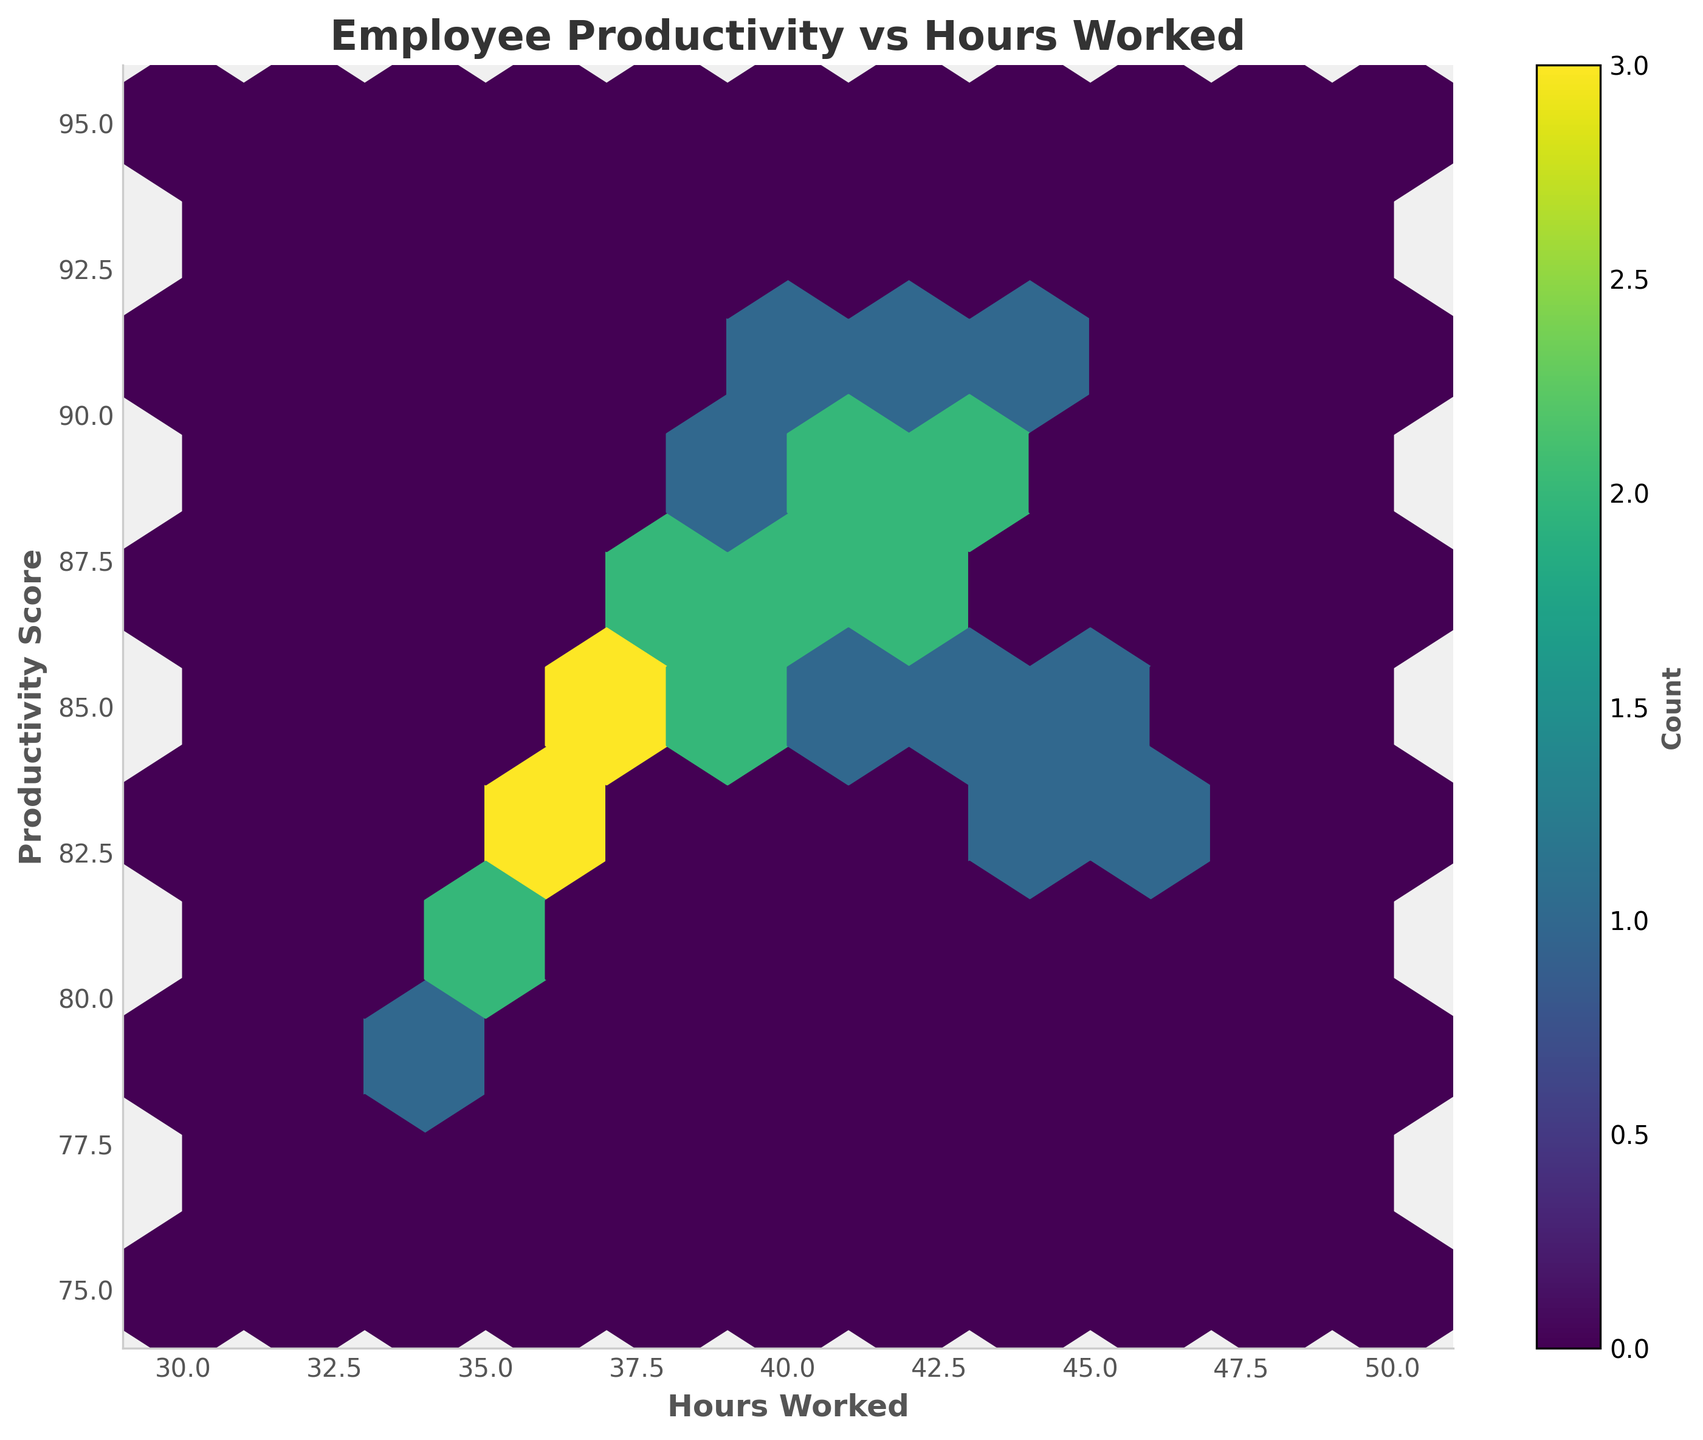What is the title of the plot? The title of the plot is usually found at the top center of the figure. It provides a brief description of what the plot represents.
Answer: Employee Productivity vs Hours Worked What are the labels of the x and y axes? The labels of the x and y axes are found along the axes. The x-axis typically represents the independent variable, and the y-axis represents the dependent variable in the plot.
Answer: Hours Worked, Productivity Score What color scheme is used in the hexbin plot? The color scheme of the hexbin plot can be identified by looking at the different shades used to represent the density of data points. In this case, it is a gradient of a single color.
Answer: Viridis How many bins appear to contain the highest density of data points? The hexbin plot uses hexagonal bins to indicate data density. The bins with the highest density are the darkest or most saturated in color.
Answer: 1-2 bins (depending on exact densest spots) What is the productivity score range for employees who work between 40 and 45 hours? Find the approximate range of productivity scores for employees within the specified hours. Observe the concentration and spread of hexagons within this range of hours.
Answer: Approximately 83 to 91 Which hexagonal bin has the least density, and what are the corresponding hours worked and productivity score range? Identify the bins with the lightest color or low saturation, indicating fewer data points within that bin. Check the range of hours and productivity score it covers.
Answer: Least dense bin is around (34-36 hours, 80-82 productivity score) Do higher hours worked correlate with higher productivity scores? Observe the general trend of the data distribution in the hexbin plot. If higher productivity scores are consistently found with higher hours worked, it indicates a positive correlation.
Answer: Yes, a slight positive correlation What is the average productivity score for employees who work 38 hours? Isolate the hexagonal bins around the 38-hour mark and note the average productivity scores represented in those bins.
Answer: Approximately 87 Among employees with the same productivity score, who works fewer hours on average, those in roles requiring technical skills or those in managerial roles? Considering groups with similar productivity scores, compare the hours worked between technical roles (like software engineers) and managerial roles (like project managers).
Answer: Technical roles work slightly fewer hours Do the color bar labels indicate exact or approximate counts of data points in each bin? Examine the color bar on the right side of the plot. It usually provides information on whether the values are exact counts or approximate counts.
Answer: Approximate counts 